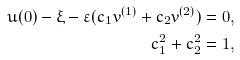Convert formula to latex. <formula><loc_0><loc_0><loc_500><loc_500>u ( 0 ) - \xi - \varepsilon ( c _ { 1 } v ^ { ( 1 ) } + c _ { 2 } v ^ { ( 2 ) } ) & = 0 , \\ c _ { 1 } ^ { 2 } + c _ { 2 } ^ { 2 } & = 1 ,</formula> 